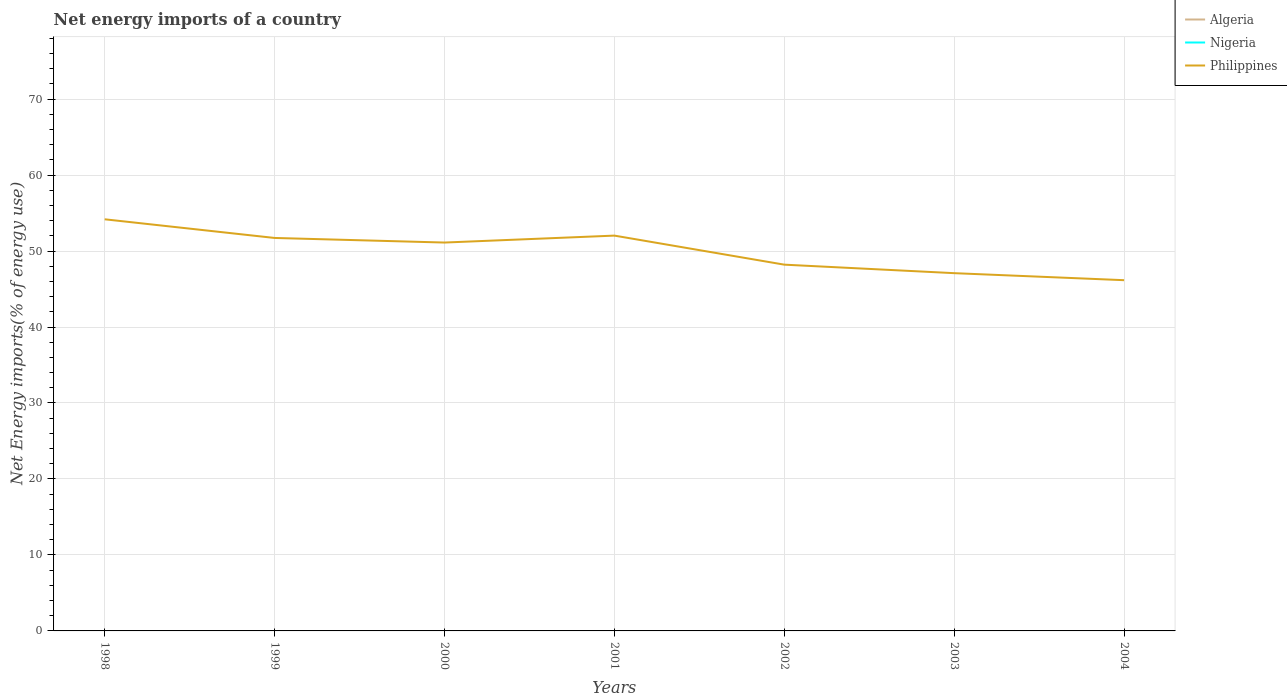Does the line corresponding to Algeria intersect with the line corresponding to Nigeria?
Provide a short and direct response. No. Across all years, what is the maximum net energy imports in Nigeria?
Provide a succinct answer. 0. What is the total net energy imports in Philippines in the graph?
Offer a very short reply. 2.91. What is the difference between the highest and the second highest net energy imports in Philippines?
Offer a terse response. 8.02. What is the difference between two consecutive major ticks on the Y-axis?
Offer a terse response. 10. Does the graph contain grids?
Your response must be concise. Yes. Where does the legend appear in the graph?
Your response must be concise. Top right. How are the legend labels stacked?
Your answer should be compact. Vertical. What is the title of the graph?
Your answer should be very brief. Net energy imports of a country. What is the label or title of the Y-axis?
Offer a very short reply. Net Energy imports(% of energy use). What is the Net Energy imports(% of energy use) in Nigeria in 1998?
Provide a succinct answer. 0. What is the Net Energy imports(% of energy use) of Philippines in 1998?
Provide a short and direct response. 54.18. What is the Net Energy imports(% of energy use) in Philippines in 1999?
Your answer should be compact. 51.72. What is the Net Energy imports(% of energy use) in Philippines in 2000?
Give a very brief answer. 51.12. What is the Net Energy imports(% of energy use) in Nigeria in 2001?
Keep it short and to the point. 0. What is the Net Energy imports(% of energy use) of Philippines in 2001?
Make the answer very short. 52.03. What is the Net Energy imports(% of energy use) in Algeria in 2002?
Give a very brief answer. 0. What is the Net Energy imports(% of energy use) of Philippines in 2002?
Your response must be concise. 48.21. What is the Net Energy imports(% of energy use) in Algeria in 2003?
Your response must be concise. 0. What is the Net Energy imports(% of energy use) in Philippines in 2003?
Make the answer very short. 47.09. What is the Net Energy imports(% of energy use) of Nigeria in 2004?
Your answer should be compact. 0. What is the Net Energy imports(% of energy use) of Philippines in 2004?
Make the answer very short. 46.16. Across all years, what is the maximum Net Energy imports(% of energy use) of Philippines?
Your answer should be very brief. 54.18. Across all years, what is the minimum Net Energy imports(% of energy use) of Philippines?
Provide a succinct answer. 46.16. What is the total Net Energy imports(% of energy use) in Algeria in the graph?
Your answer should be compact. 0. What is the total Net Energy imports(% of energy use) in Nigeria in the graph?
Provide a succinct answer. 0. What is the total Net Energy imports(% of energy use) in Philippines in the graph?
Keep it short and to the point. 350.5. What is the difference between the Net Energy imports(% of energy use) in Philippines in 1998 and that in 1999?
Your answer should be very brief. 2.46. What is the difference between the Net Energy imports(% of energy use) in Philippines in 1998 and that in 2000?
Offer a very short reply. 3.06. What is the difference between the Net Energy imports(% of energy use) in Philippines in 1998 and that in 2001?
Provide a succinct answer. 2.15. What is the difference between the Net Energy imports(% of energy use) in Philippines in 1998 and that in 2002?
Make the answer very short. 5.97. What is the difference between the Net Energy imports(% of energy use) of Philippines in 1998 and that in 2003?
Your answer should be very brief. 7.09. What is the difference between the Net Energy imports(% of energy use) in Philippines in 1998 and that in 2004?
Make the answer very short. 8.02. What is the difference between the Net Energy imports(% of energy use) in Philippines in 1999 and that in 2000?
Your answer should be very brief. 0.6. What is the difference between the Net Energy imports(% of energy use) in Philippines in 1999 and that in 2001?
Provide a succinct answer. -0.31. What is the difference between the Net Energy imports(% of energy use) of Philippines in 1999 and that in 2002?
Make the answer very short. 3.51. What is the difference between the Net Energy imports(% of energy use) in Philippines in 1999 and that in 2003?
Your answer should be very brief. 4.63. What is the difference between the Net Energy imports(% of energy use) in Philippines in 1999 and that in 2004?
Provide a succinct answer. 5.56. What is the difference between the Net Energy imports(% of energy use) of Philippines in 2000 and that in 2001?
Give a very brief answer. -0.91. What is the difference between the Net Energy imports(% of energy use) of Philippines in 2000 and that in 2002?
Provide a short and direct response. 2.91. What is the difference between the Net Energy imports(% of energy use) of Philippines in 2000 and that in 2003?
Provide a succinct answer. 4.03. What is the difference between the Net Energy imports(% of energy use) in Philippines in 2000 and that in 2004?
Your answer should be compact. 4.95. What is the difference between the Net Energy imports(% of energy use) in Philippines in 2001 and that in 2002?
Offer a terse response. 3.82. What is the difference between the Net Energy imports(% of energy use) in Philippines in 2001 and that in 2003?
Keep it short and to the point. 4.94. What is the difference between the Net Energy imports(% of energy use) in Philippines in 2001 and that in 2004?
Provide a short and direct response. 5.87. What is the difference between the Net Energy imports(% of energy use) of Philippines in 2002 and that in 2003?
Provide a short and direct response. 1.12. What is the difference between the Net Energy imports(% of energy use) in Philippines in 2002 and that in 2004?
Provide a short and direct response. 2.04. What is the difference between the Net Energy imports(% of energy use) of Philippines in 2003 and that in 2004?
Your answer should be compact. 0.92. What is the average Net Energy imports(% of energy use) of Algeria per year?
Your response must be concise. 0. What is the average Net Energy imports(% of energy use) in Philippines per year?
Offer a very short reply. 50.07. What is the ratio of the Net Energy imports(% of energy use) of Philippines in 1998 to that in 1999?
Your answer should be very brief. 1.05. What is the ratio of the Net Energy imports(% of energy use) of Philippines in 1998 to that in 2000?
Provide a succinct answer. 1.06. What is the ratio of the Net Energy imports(% of energy use) of Philippines in 1998 to that in 2001?
Provide a succinct answer. 1.04. What is the ratio of the Net Energy imports(% of energy use) in Philippines in 1998 to that in 2002?
Your response must be concise. 1.12. What is the ratio of the Net Energy imports(% of energy use) of Philippines in 1998 to that in 2003?
Your answer should be very brief. 1.15. What is the ratio of the Net Energy imports(% of energy use) in Philippines in 1998 to that in 2004?
Offer a very short reply. 1.17. What is the ratio of the Net Energy imports(% of energy use) of Philippines in 1999 to that in 2000?
Make the answer very short. 1.01. What is the ratio of the Net Energy imports(% of energy use) of Philippines in 1999 to that in 2002?
Give a very brief answer. 1.07. What is the ratio of the Net Energy imports(% of energy use) of Philippines in 1999 to that in 2003?
Offer a terse response. 1.1. What is the ratio of the Net Energy imports(% of energy use) in Philippines in 1999 to that in 2004?
Provide a short and direct response. 1.12. What is the ratio of the Net Energy imports(% of energy use) of Philippines in 2000 to that in 2001?
Offer a very short reply. 0.98. What is the ratio of the Net Energy imports(% of energy use) in Philippines in 2000 to that in 2002?
Ensure brevity in your answer.  1.06. What is the ratio of the Net Energy imports(% of energy use) of Philippines in 2000 to that in 2003?
Make the answer very short. 1.09. What is the ratio of the Net Energy imports(% of energy use) of Philippines in 2000 to that in 2004?
Offer a very short reply. 1.11. What is the ratio of the Net Energy imports(% of energy use) in Philippines in 2001 to that in 2002?
Your answer should be compact. 1.08. What is the ratio of the Net Energy imports(% of energy use) in Philippines in 2001 to that in 2003?
Ensure brevity in your answer.  1.1. What is the ratio of the Net Energy imports(% of energy use) in Philippines in 2001 to that in 2004?
Make the answer very short. 1.13. What is the ratio of the Net Energy imports(% of energy use) of Philippines in 2002 to that in 2003?
Offer a very short reply. 1.02. What is the ratio of the Net Energy imports(% of energy use) in Philippines in 2002 to that in 2004?
Keep it short and to the point. 1.04. What is the difference between the highest and the second highest Net Energy imports(% of energy use) of Philippines?
Keep it short and to the point. 2.15. What is the difference between the highest and the lowest Net Energy imports(% of energy use) in Philippines?
Provide a succinct answer. 8.02. 